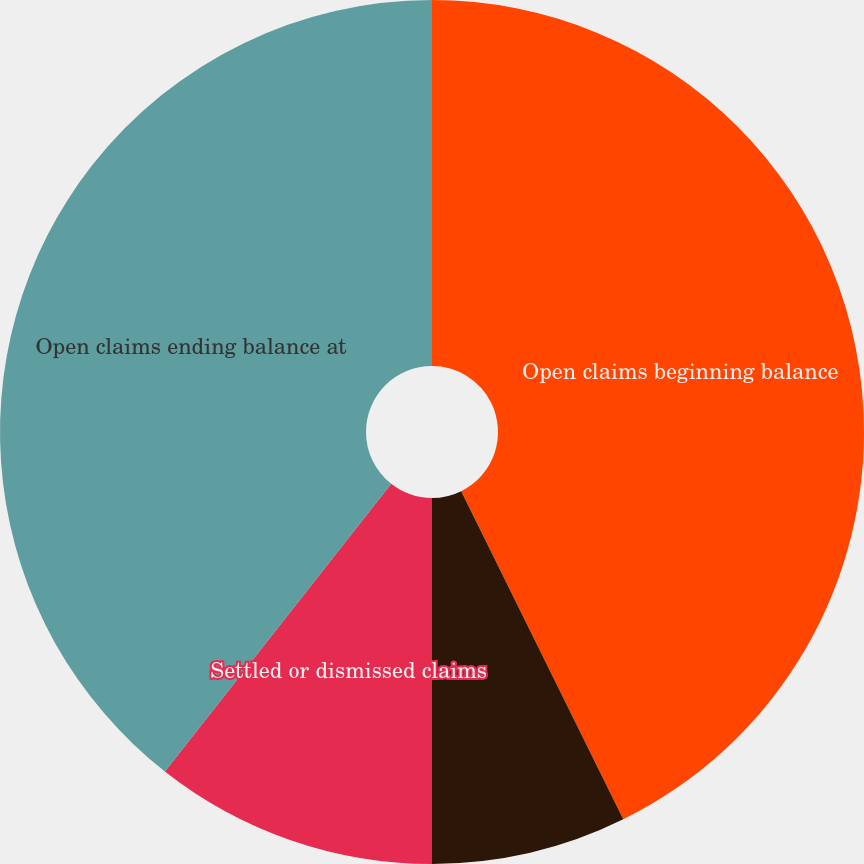<chart> <loc_0><loc_0><loc_500><loc_500><pie_chart><fcel>Open claims beginning balance<fcel>New claims<fcel>Settled or dismissed claims<fcel>Open claims ending balance at<nl><fcel>42.7%<fcel>7.3%<fcel>10.61%<fcel>39.39%<nl></chart> 